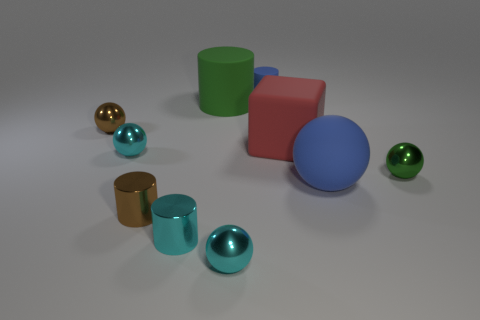What number of tiny objects are rubber cylinders or blue spheres?
Ensure brevity in your answer.  1. Does the tiny shiny ball in front of the cyan cylinder have the same color as the rubber sphere?
Your answer should be very brief. No. There is a tiny shiny sphere that is in front of the tiny cyan cylinder; is it the same color as the metallic ball that is on the right side of the big rubber ball?
Provide a short and direct response. No. Are there any big red blocks made of the same material as the tiny brown cylinder?
Offer a very short reply. No. How many cyan objects are either spheres or blocks?
Make the answer very short. 2. Is the number of rubber cylinders behind the big rubber cylinder greater than the number of small balls?
Offer a very short reply. No. Do the green metallic thing and the blue cylinder have the same size?
Make the answer very short. Yes. What color is the block that is made of the same material as the large ball?
Your response must be concise. Red. The metallic thing that is the same color as the big cylinder is what shape?
Your answer should be compact. Sphere. Are there the same number of small green metallic spheres behind the large cylinder and big rubber objects that are on the left side of the large red rubber object?
Offer a very short reply. No. 